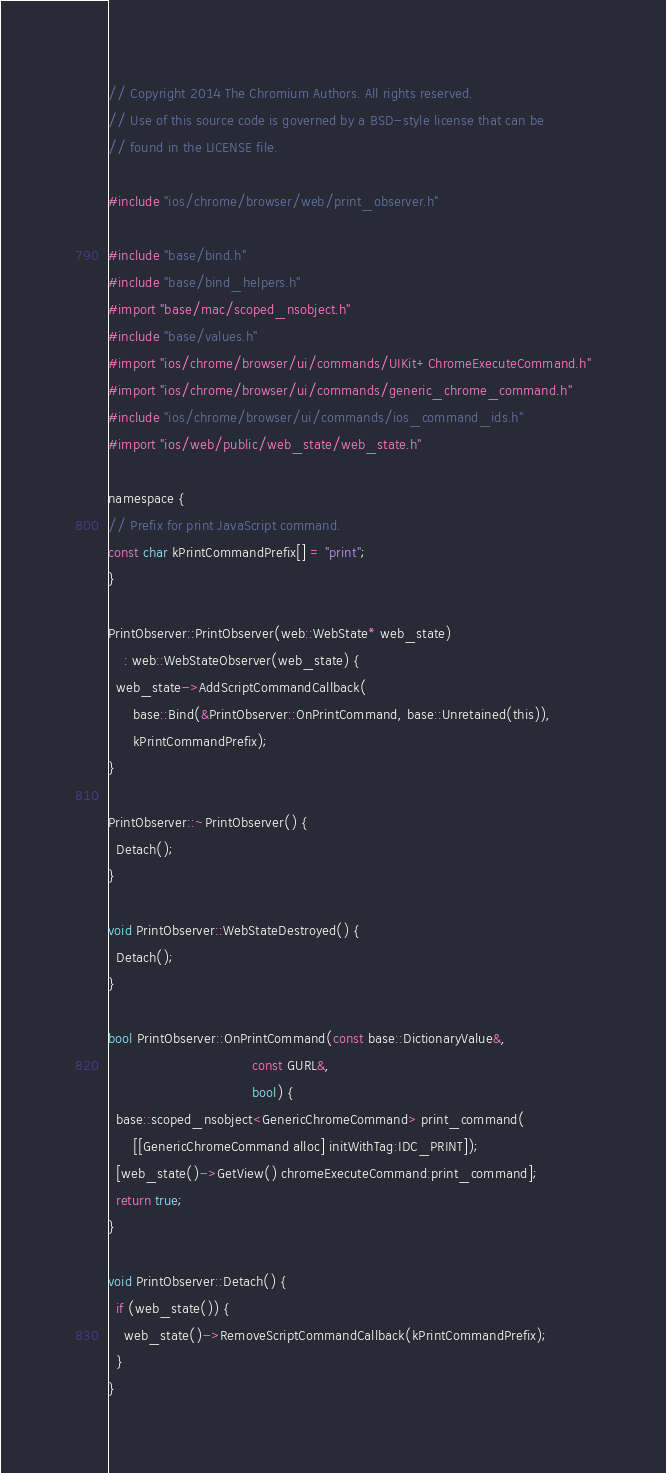<code> <loc_0><loc_0><loc_500><loc_500><_ObjectiveC_>// Copyright 2014 The Chromium Authors. All rights reserved.
// Use of this source code is governed by a BSD-style license that can be
// found in the LICENSE file.

#include "ios/chrome/browser/web/print_observer.h"

#include "base/bind.h"
#include "base/bind_helpers.h"
#import "base/mac/scoped_nsobject.h"
#include "base/values.h"
#import "ios/chrome/browser/ui/commands/UIKit+ChromeExecuteCommand.h"
#import "ios/chrome/browser/ui/commands/generic_chrome_command.h"
#include "ios/chrome/browser/ui/commands/ios_command_ids.h"
#import "ios/web/public/web_state/web_state.h"

namespace {
// Prefix for print JavaScript command.
const char kPrintCommandPrefix[] = "print";
}

PrintObserver::PrintObserver(web::WebState* web_state)
    : web::WebStateObserver(web_state) {
  web_state->AddScriptCommandCallback(
      base::Bind(&PrintObserver::OnPrintCommand, base::Unretained(this)),
      kPrintCommandPrefix);
}

PrintObserver::~PrintObserver() {
  Detach();
}

void PrintObserver::WebStateDestroyed() {
  Detach();
}

bool PrintObserver::OnPrintCommand(const base::DictionaryValue&,
                                   const GURL&,
                                   bool) {
  base::scoped_nsobject<GenericChromeCommand> print_command(
      [[GenericChromeCommand alloc] initWithTag:IDC_PRINT]);
  [web_state()->GetView() chromeExecuteCommand:print_command];
  return true;
}

void PrintObserver::Detach() {
  if (web_state()) {
    web_state()->RemoveScriptCommandCallback(kPrintCommandPrefix);
  }
}
</code> 